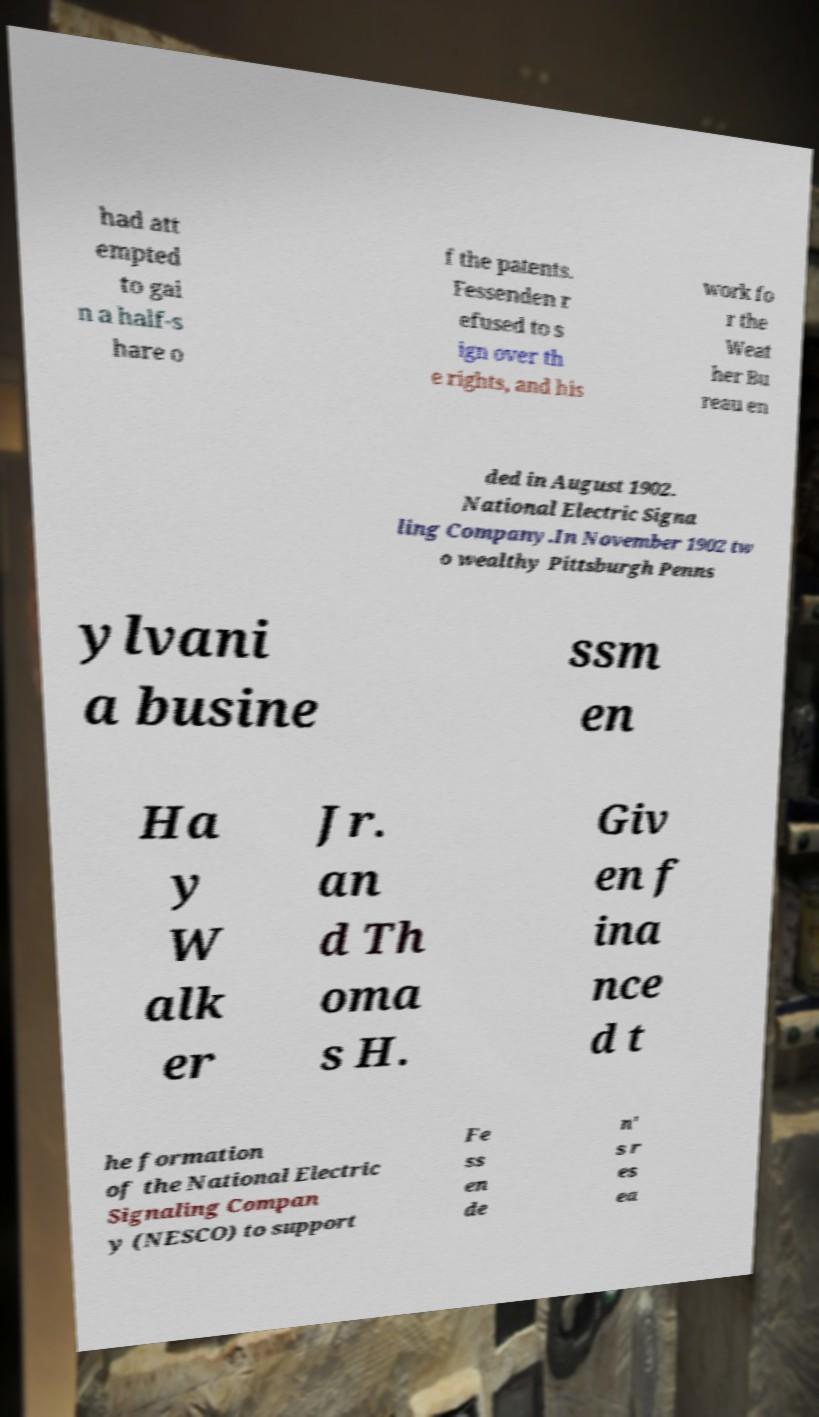Please identify and transcribe the text found in this image. had att empted to gai n a half-s hare o f the patents. Fessenden r efused to s ign over th e rights, and his work fo r the Weat her Bu reau en ded in August 1902. National Electric Signa ling Company.In November 1902 tw o wealthy Pittsburgh Penns ylvani a busine ssm en Ha y W alk er Jr. an d Th oma s H. Giv en f ina nce d t he formation of the National Electric Signaling Compan y (NESCO) to support Fe ss en de n' s r es ea 